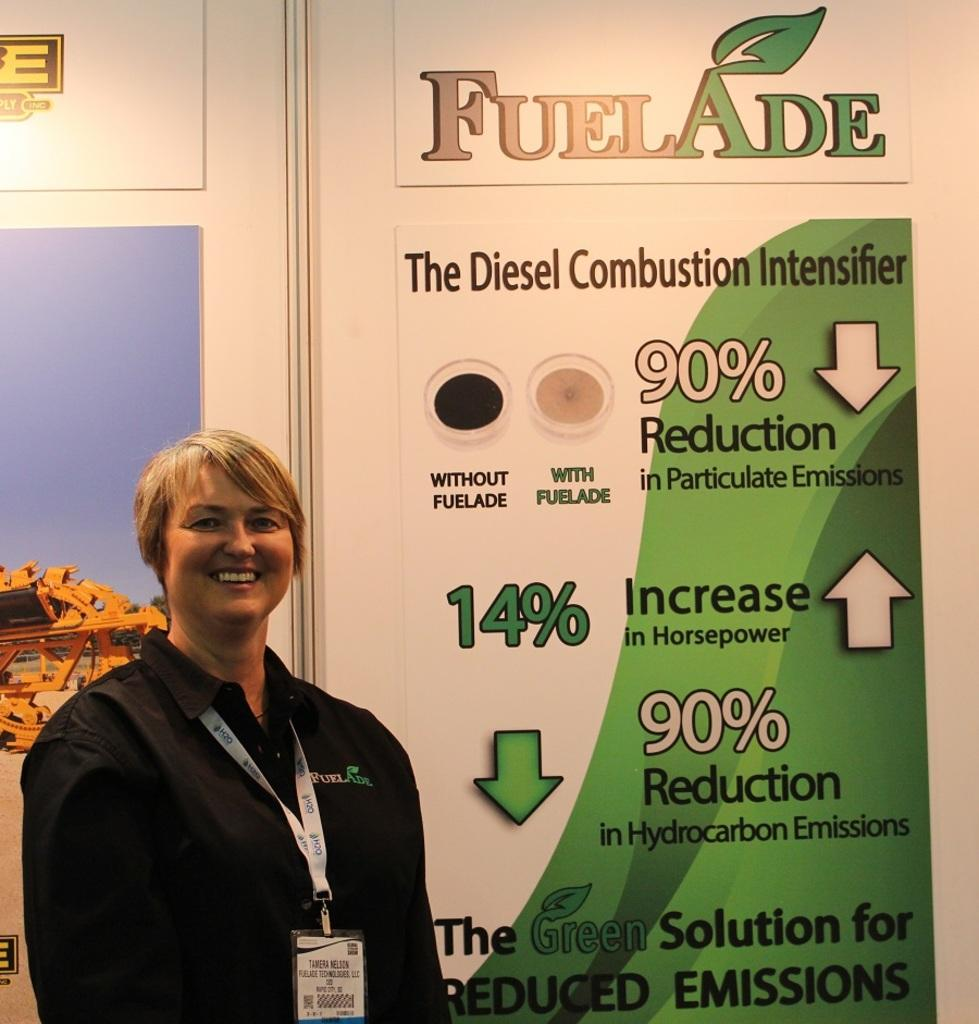Who is present in the image? There is a woman in the image. What is the woman doing in the image? The woman is standing and smiling. What can be seen in the background of the image? There is an advertisement in the background of the image. What route does the woman take to reach the nation depicted in the advertisement? There is no information about a route or a nation in the image, as it only shows a woman standing and smiling with an advertisement in the background. 